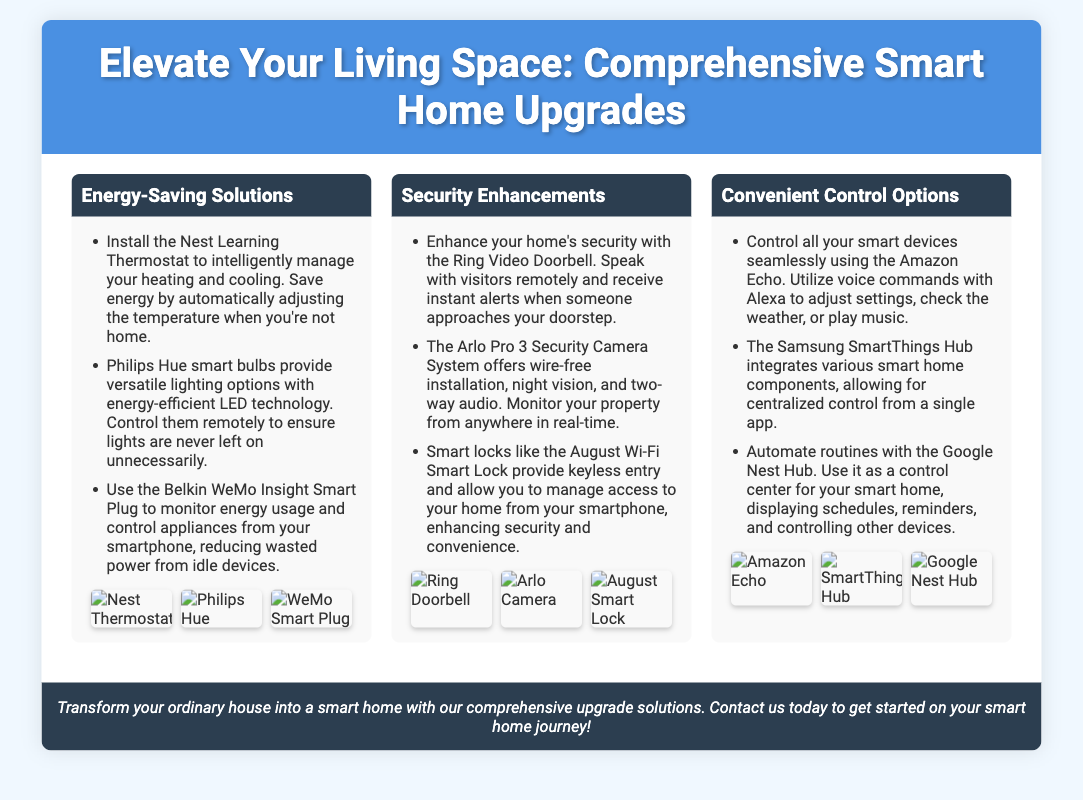What is the title of the flyer? The title is prominently displayed at the top of the flyer, introducing the main theme of the document.
Answer: Elevate Your Living Space: Comprehensive Smart Home Upgrades What device is recommended for energy-saving? The document lists specific devices and their purposes in the energy-saving section, highlighting one primary recommendation.
Answer: Nest Learning Thermostat Which security camera system is mentioned? The flyer provides information on particular security systems under the security enhancements section, specifically noting one of them.
Answer: Arlo Pro 3 Security Camera System How many sections are in the flyer? The flyer is divided into different sections, each focusing on a particular aspect of smart home upgrades.
Answer: Three What control option uses voice commands? The flyer details convenient control options and identifies a key device that enables hands-free interaction.
Answer: Amazon Echo What feature does the August Wi-Fi Smart Lock provide? This device is highlighted for enhancing security, specifically noted for one of its main characteristics.
Answer: Keyless entry What is the primary color of the header? The flyer visually presents information and color choices that can be easily observed at the top of the document.
Answer: Blue Which hub allows for centralized control? One device in the convenient control options section is identified for its ability to manage various smart components effectively.
Answer: Samsung SmartThings Hub 